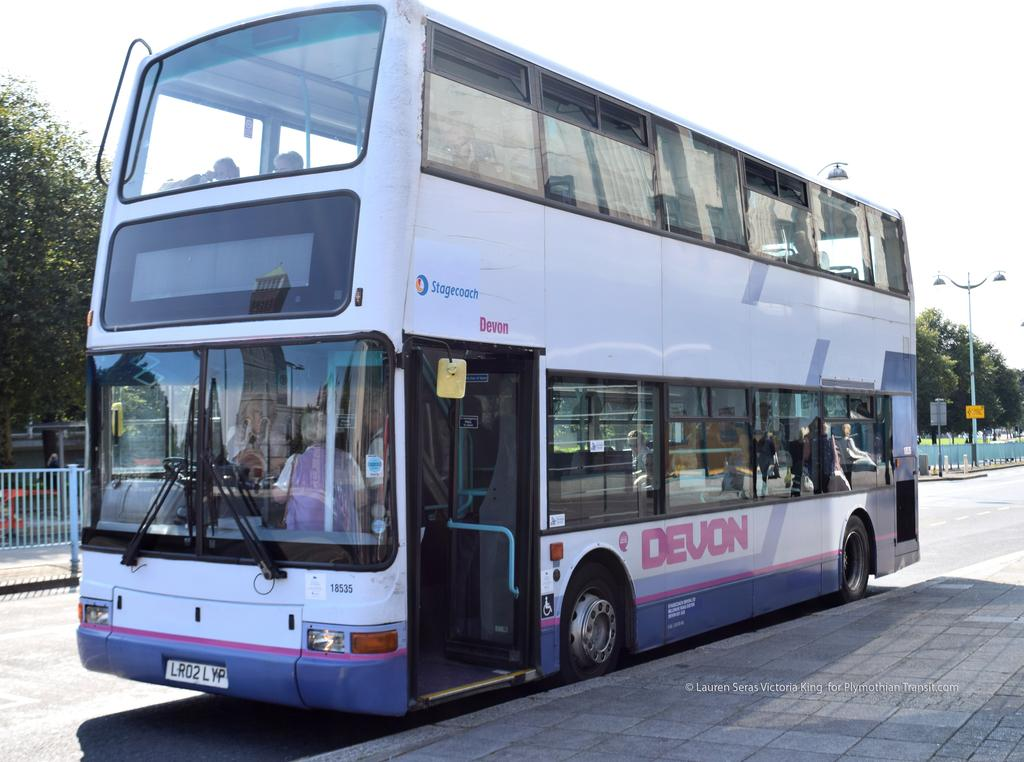<image>
Present a compact description of the photo's key features. A Devon Stagecoach double decker bus picking up a passenger 